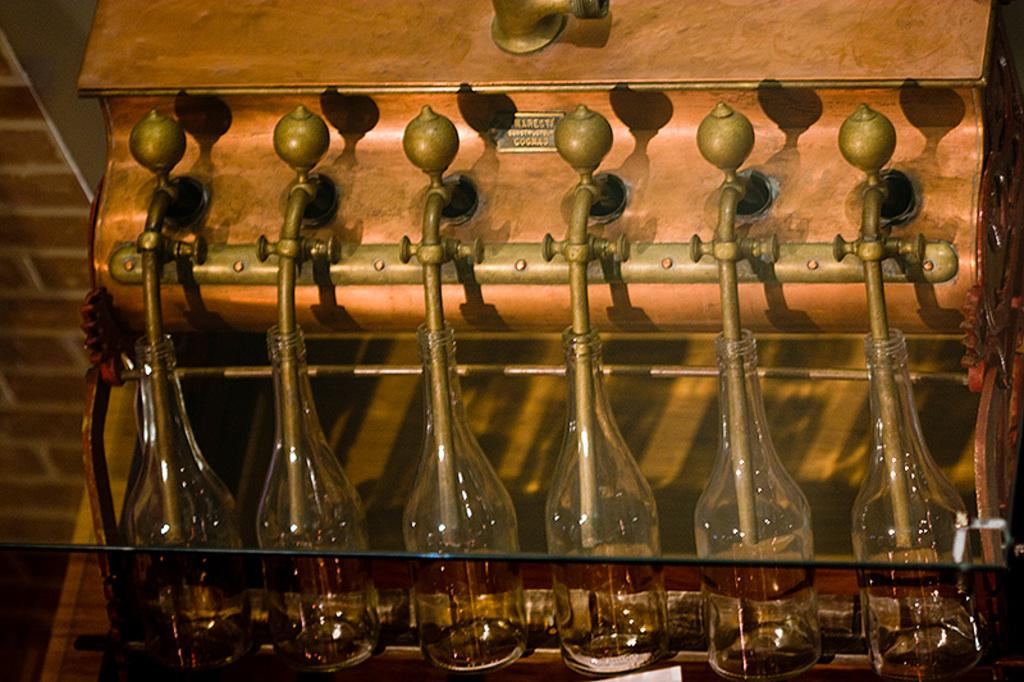What is the main subject of the image? The main subject of the image is a brewing machine. What else can be seen in the image besides the brewing machine? There are bottles in the image. What time of day is the laborer working in the image? There is no laborer present in the image, so it is not possible to determine the time of day they might be working. 